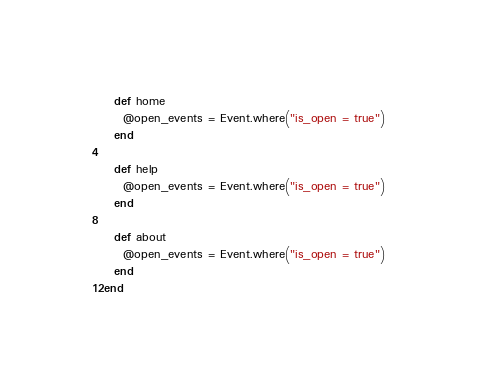<code> <loc_0><loc_0><loc_500><loc_500><_Ruby_>  def home
    @open_events = Event.where("is_open = true")
  end

  def help
    @open_events = Event.where("is_open = true")
  end

  def about
    @open_events = Event.where("is_open = true")
  end
end
</code> 